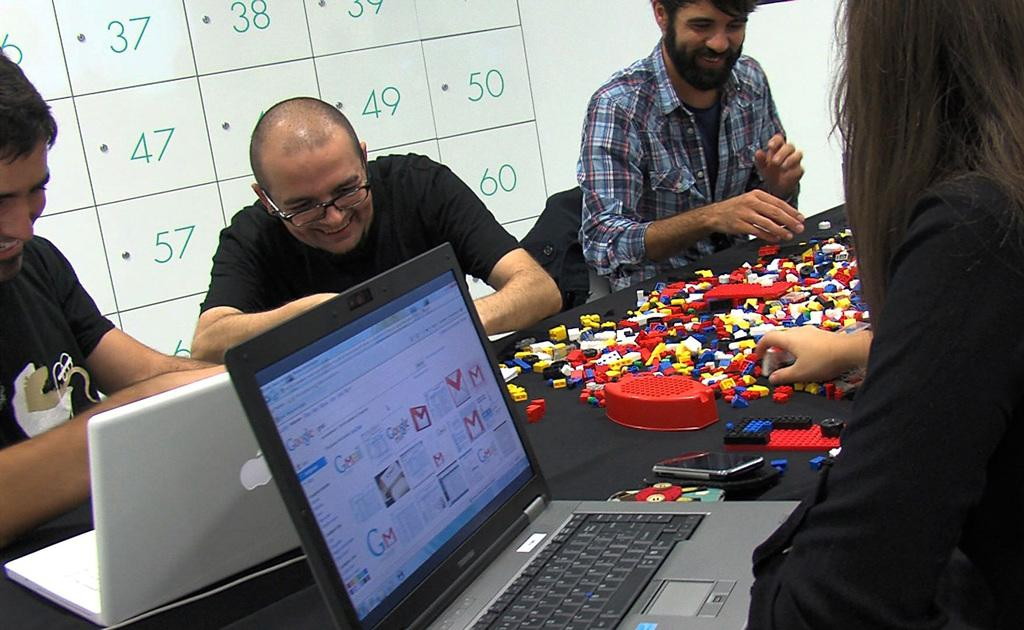<image>
Present a compact description of the photo's key features. Men playing with legos with a white board behind them with the number 50 on it. 